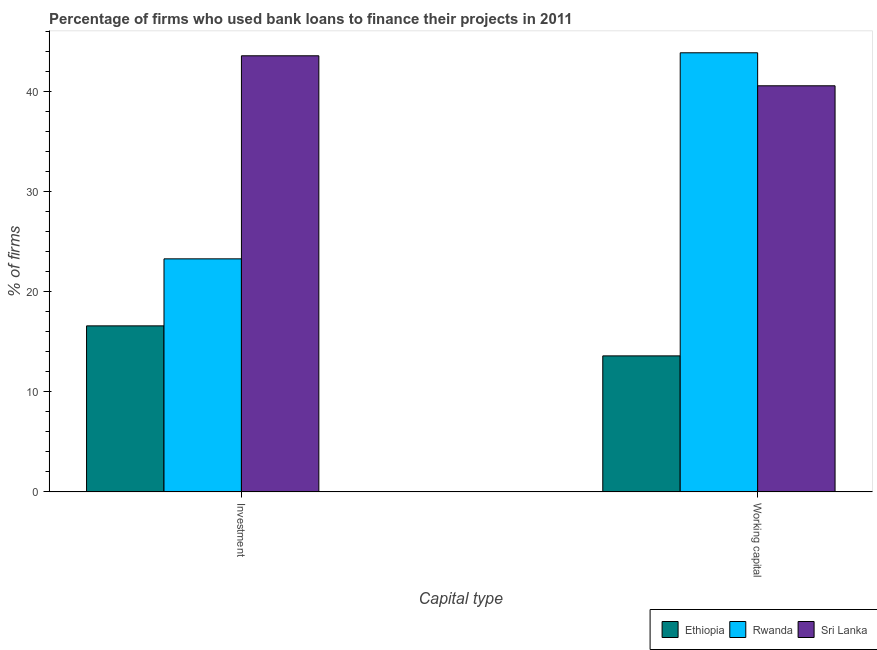How many different coloured bars are there?
Provide a short and direct response. 3. Are the number of bars per tick equal to the number of legend labels?
Your response must be concise. Yes. What is the label of the 1st group of bars from the left?
Offer a very short reply. Investment. What is the percentage of firms using banks to finance working capital in Rwanda?
Give a very brief answer. 43.9. Across all countries, what is the maximum percentage of firms using banks to finance working capital?
Ensure brevity in your answer.  43.9. Across all countries, what is the minimum percentage of firms using banks to finance working capital?
Your response must be concise. 13.6. In which country was the percentage of firms using banks to finance working capital maximum?
Offer a terse response. Rwanda. In which country was the percentage of firms using banks to finance working capital minimum?
Give a very brief answer. Ethiopia. What is the total percentage of firms using banks to finance working capital in the graph?
Your response must be concise. 98.1. What is the difference between the percentage of firms using banks to finance working capital in Ethiopia and that in Rwanda?
Offer a very short reply. -30.3. What is the difference between the percentage of firms using banks to finance working capital in Rwanda and the percentage of firms using banks to finance investment in Sri Lanka?
Provide a succinct answer. 0.3. What is the average percentage of firms using banks to finance investment per country?
Your response must be concise. 27.83. What is the difference between the percentage of firms using banks to finance investment and percentage of firms using banks to finance working capital in Rwanda?
Give a very brief answer. -20.6. In how many countries, is the percentage of firms using banks to finance investment greater than 38 %?
Keep it short and to the point. 1. What is the ratio of the percentage of firms using banks to finance working capital in Ethiopia to that in Rwanda?
Provide a succinct answer. 0.31. Is the percentage of firms using banks to finance working capital in Sri Lanka less than that in Rwanda?
Make the answer very short. Yes. What does the 1st bar from the left in Investment represents?
Provide a succinct answer. Ethiopia. What does the 2nd bar from the right in Working capital represents?
Provide a succinct answer. Rwanda. Does the graph contain grids?
Ensure brevity in your answer.  No. Where does the legend appear in the graph?
Provide a succinct answer. Bottom right. How many legend labels are there?
Keep it short and to the point. 3. What is the title of the graph?
Offer a terse response. Percentage of firms who used bank loans to finance their projects in 2011. Does "High income" appear as one of the legend labels in the graph?
Ensure brevity in your answer.  No. What is the label or title of the X-axis?
Make the answer very short. Capital type. What is the label or title of the Y-axis?
Provide a succinct answer. % of firms. What is the % of firms of Rwanda in Investment?
Offer a terse response. 23.3. What is the % of firms of Sri Lanka in Investment?
Offer a terse response. 43.6. What is the % of firms of Rwanda in Working capital?
Offer a very short reply. 43.9. What is the % of firms in Sri Lanka in Working capital?
Give a very brief answer. 40.6. Across all Capital type, what is the maximum % of firms in Rwanda?
Provide a short and direct response. 43.9. Across all Capital type, what is the maximum % of firms of Sri Lanka?
Give a very brief answer. 43.6. Across all Capital type, what is the minimum % of firms of Ethiopia?
Keep it short and to the point. 13.6. Across all Capital type, what is the minimum % of firms in Rwanda?
Your response must be concise. 23.3. Across all Capital type, what is the minimum % of firms of Sri Lanka?
Your response must be concise. 40.6. What is the total % of firms of Ethiopia in the graph?
Provide a short and direct response. 30.2. What is the total % of firms of Rwanda in the graph?
Make the answer very short. 67.2. What is the total % of firms of Sri Lanka in the graph?
Give a very brief answer. 84.2. What is the difference between the % of firms of Ethiopia in Investment and that in Working capital?
Provide a short and direct response. 3. What is the difference between the % of firms in Rwanda in Investment and that in Working capital?
Your answer should be very brief. -20.6. What is the difference between the % of firms of Sri Lanka in Investment and that in Working capital?
Offer a terse response. 3. What is the difference between the % of firms of Ethiopia in Investment and the % of firms of Rwanda in Working capital?
Offer a terse response. -27.3. What is the difference between the % of firms of Ethiopia in Investment and the % of firms of Sri Lanka in Working capital?
Give a very brief answer. -24. What is the difference between the % of firms in Rwanda in Investment and the % of firms in Sri Lanka in Working capital?
Give a very brief answer. -17.3. What is the average % of firms of Rwanda per Capital type?
Provide a succinct answer. 33.6. What is the average % of firms of Sri Lanka per Capital type?
Give a very brief answer. 42.1. What is the difference between the % of firms of Rwanda and % of firms of Sri Lanka in Investment?
Keep it short and to the point. -20.3. What is the difference between the % of firms in Ethiopia and % of firms in Rwanda in Working capital?
Your answer should be compact. -30.3. What is the difference between the % of firms of Rwanda and % of firms of Sri Lanka in Working capital?
Ensure brevity in your answer.  3.3. What is the ratio of the % of firms of Ethiopia in Investment to that in Working capital?
Your answer should be very brief. 1.22. What is the ratio of the % of firms of Rwanda in Investment to that in Working capital?
Offer a very short reply. 0.53. What is the ratio of the % of firms in Sri Lanka in Investment to that in Working capital?
Your answer should be very brief. 1.07. What is the difference between the highest and the second highest % of firms of Ethiopia?
Ensure brevity in your answer.  3. What is the difference between the highest and the second highest % of firms in Rwanda?
Your response must be concise. 20.6. What is the difference between the highest and the second highest % of firms of Sri Lanka?
Give a very brief answer. 3. What is the difference between the highest and the lowest % of firms in Ethiopia?
Provide a short and direct response. 3. What is the difference between the highest and the lowest % of firms of Rwanda?
Offer a terse response. 20.6. 